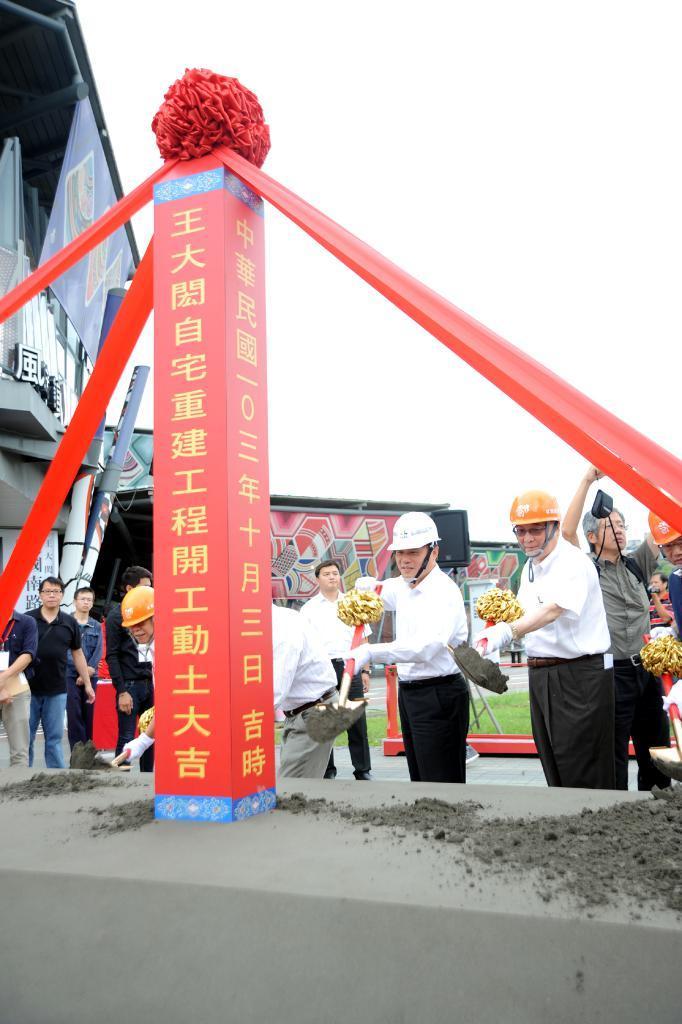In one or two sentences, can you explain what this image depicts? In this image we can see many people. There are few people holding some objects in their hand. There are few advertising boards in the image. There is a building in the image. There is a sky in the image. 